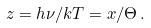<formula> <loc_0><loc_0><loc_500><loc_500>z = h \nu / k T = x / \Theta \, .</formula> 